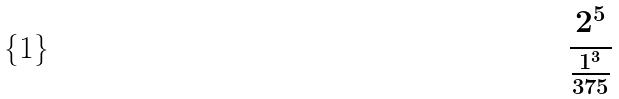<formula> <loc_0><loc_0><loc_500><loc_500>\frac { 2 ^ { 5 } } { \frac { 1 ^ { 3 } } { 3 7 5 } }</formula> 